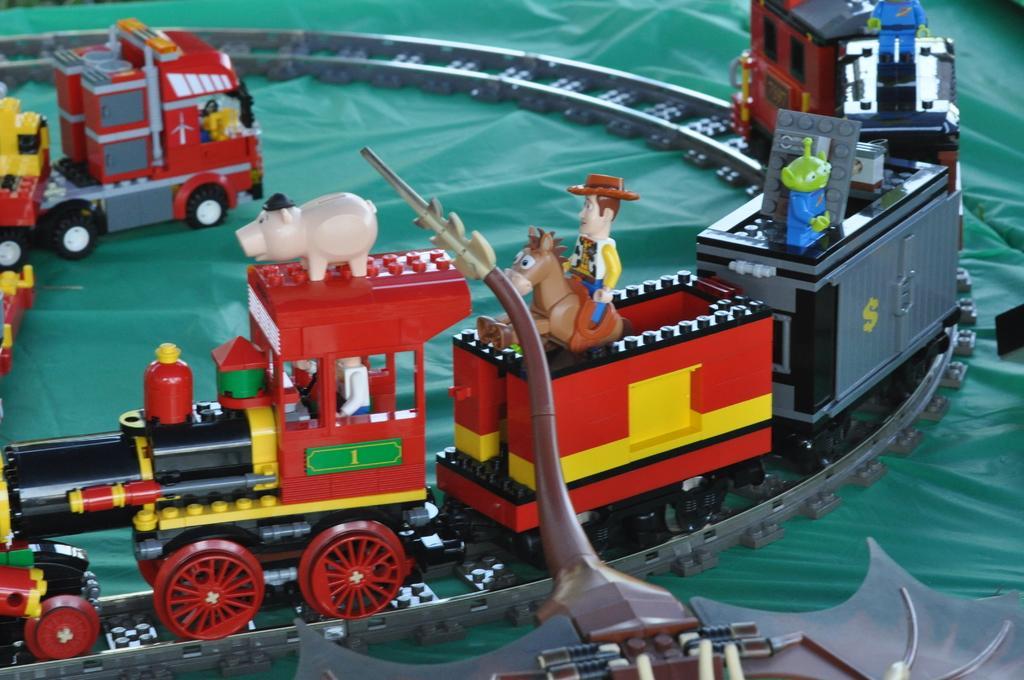Describe this image in one or two sentences. On this green surface we can see a toy train on track. On this toy train there are toys. 